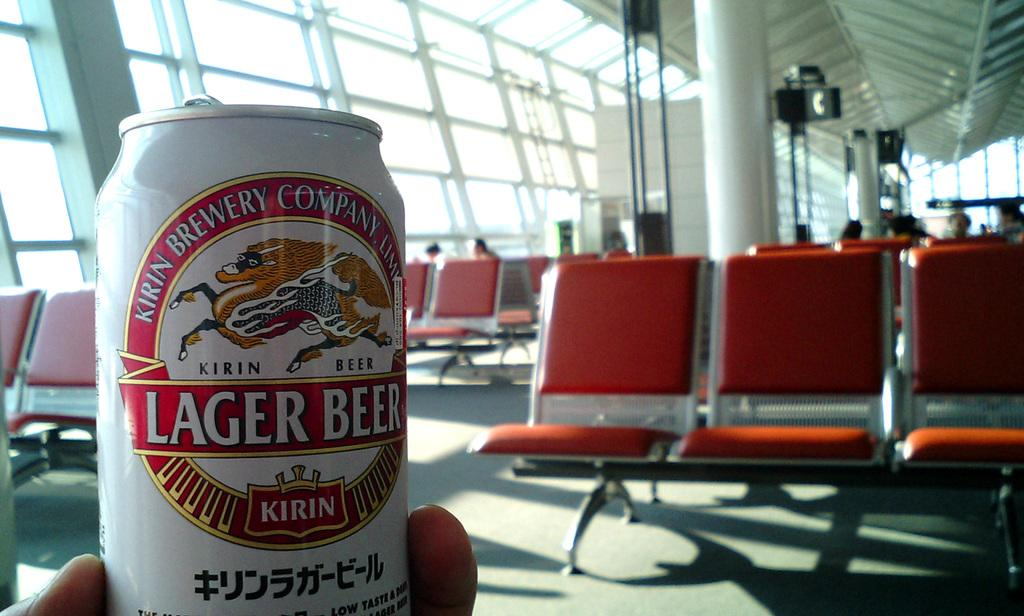Provide a one-sentence caption for the provided image. Someone holds up a Kirin Lager Beer in an airport. 